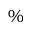Convert formula to latex. <formula><loc_0><loc_0><loc_500><loc_500>\%</formula> 